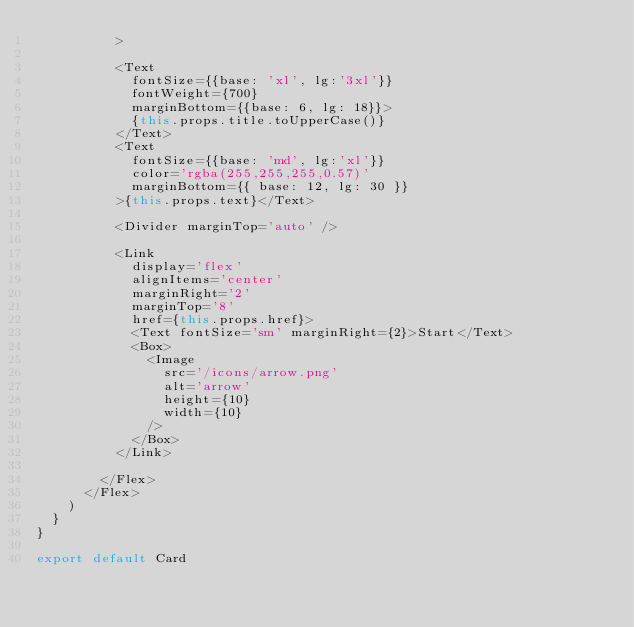<code> <loc_0><loc_0><loc_500><loc_500><_TypeScript_>          >

          <Text 
            fontSize={{base: 'xl', lg:'3xl'}}
            fontWeight={700}
            marginBottom={{base: 6, lg: 18}}>
            {this.props.title.toUpperCase()}
          </Text>
          <Text 
            fontSize={{base: 'md', lg:'xl'}}
            color='rgba(255,255,255,0.57)'
            marginBottom={{ base: 12, lg: 30 }}
          >{this.props.text}</Text>

          <Divider marginTop='auto' />

          <Link
            display='flex'
            alignItems='center'
            marginRight='2'
            marginTop='8'
            href={this.props.href}>
            <Text fontSize='sm' marginRight={2}>Start</Text>
            <Box>
              <Image
                src='/icons/arrow.png'
                alt='arrow'
                height={10}
                width={10}
              />
            </Box>
          </Link>
          
        </Flex>
      </Flex>
    )
  }
}

export default Card
</code> 